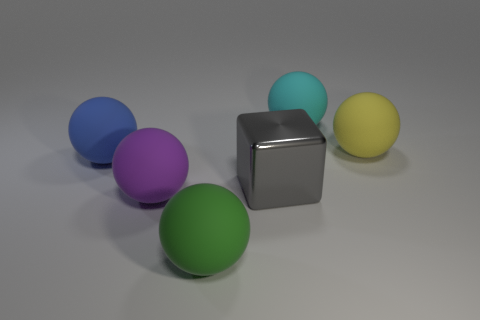There is a ball that is behind the large purple matte ball and to the left of the big cyan sphere; what is its color?
Ensure brevity in your answer.  Blue. What is the shape of the cyan rubber thing that is the same size as the cube?
Your answer should be compact. Sphere. Are there any cyan matte objects of the same shape as the large blue thing?
Make the answer very short. Yes. Is the cyan sphere made of the same material as the ball in front of the purple rubber ball?
Your answer should be very brief. Yes. What color is the matte thing right of the matte sphere behind the big rubber sphere to the right of the big cyan object?
Your response must be concise. Yellow. There is a gray thing that is the same size as the blue sphere; what is it made of?
Offer a terse response. Metal. What number of large cyan things have the same material as the large purple ball?
Offer a very short reply. 1. There is a object that is left of the purple matte thing; what is its color?
Make the answer very short. Blue. There is a gray shiny block; does it have the same size as the rubber sphere that is on the right side of the big cyan matte thing?
Your answer should be very brief. Yes. There is a object that is behind the large thing right of the large sphere that is behind the yellow ball; what is its size?
Provide a succinct answer. Large. 